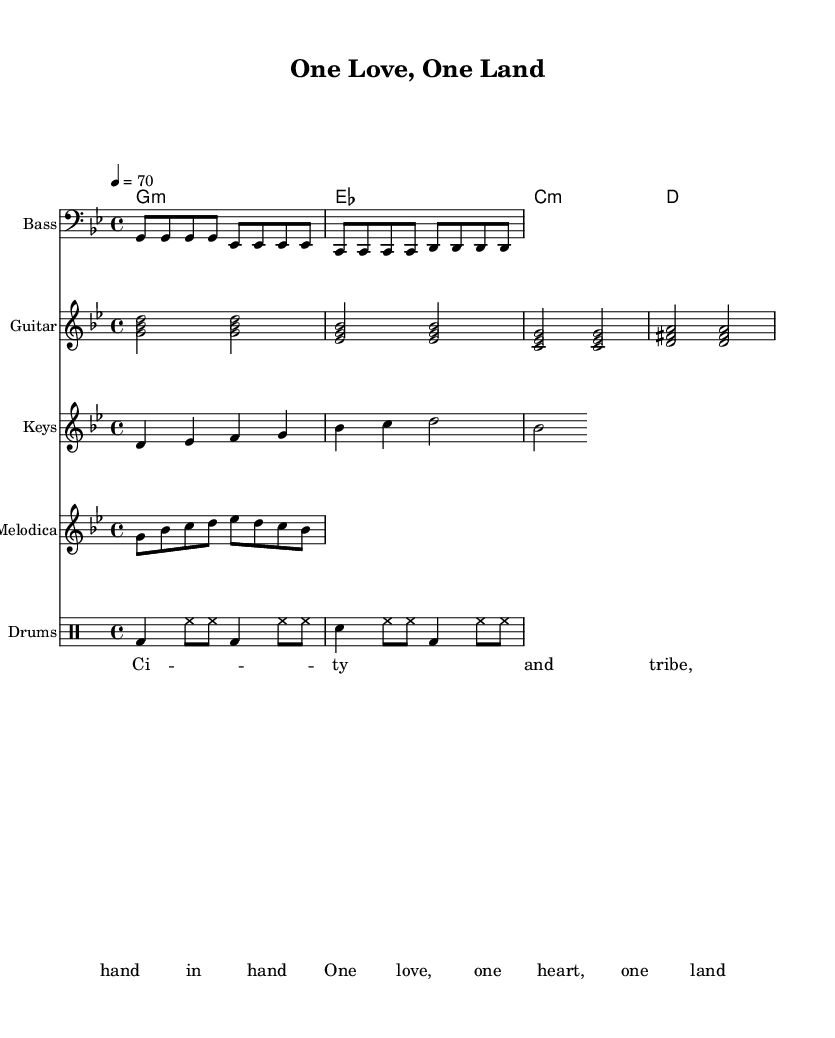What is the key signature of this music? The key signature is G minor, which is indicated by the presence of two flats (B flat and E flat).
Answer: G minor What is the time signature of this music? The time signature is 4/4, as noted at the beginning of the sheet music. This indicates there are four beats in each measure and the quarter note gets one beat.
Answer: 4/4 What is the tempo marking of this piece? The tempo marking, indicated by 4 = 70, specifies a metronome marking of 70 beats per minute for the quarter note.
Answer: 70 How many instruments are present in this music? There are six distinct parts indicated, one for Bass, one for Guitar, one for Keys, one for Melodica, one for Drums, and a section for Lyrics.
Answer: Six What is the main lyrical theme of the song? The lyrics emphasize unity and collaboration, as highlighted by the phrases 'hand in hand' and 'one love, one heart, one land.' This suggests a peaceful coexistence between city and tribal communities.
Answer: Unity Which musical style is predominantly featured in this piece? The piece features Dub reggae, characterized by its use of a steady bass line, syncopated guitar skanks, and melody elements, reflecting the genre's roots and style.
Answer: Dub reggae What rhythm do the drums primarily follow in this song? The drum patterns fit a typical reggae rhythm pattern, commonly featuring the bass drum on the downbeat and a constant hi-hat rhythm, creating a laid-back feel typical of reggae music.
Answer: Reggae rhythm 